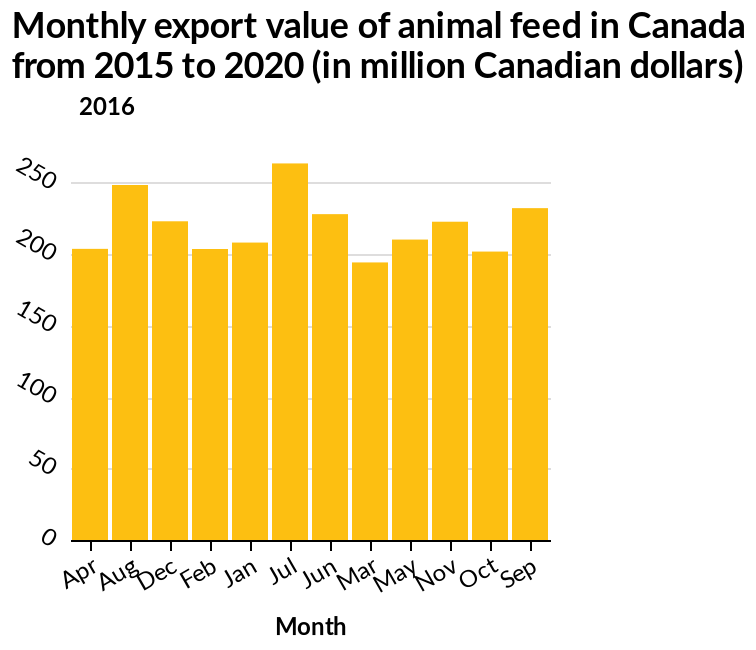<image>
Which month experienced the highest rise in value? The month that experienced the highest rise in value is July. What does the y-axis measure in the bar diagram?  The y-axis measures the Monthly export value of animal feed in million Canadian dollars. What unit of currency is used for measuring the export value? The unit of currency used for measuring the export value is Canadian dollars. Offer a thorough analysis of the image. July had the highest rise in value exceeding 250. March has the lowest drop in value falling under 200. Did July experience the lowest rise in value? No.The month that experienced the highest rise in value is July. 